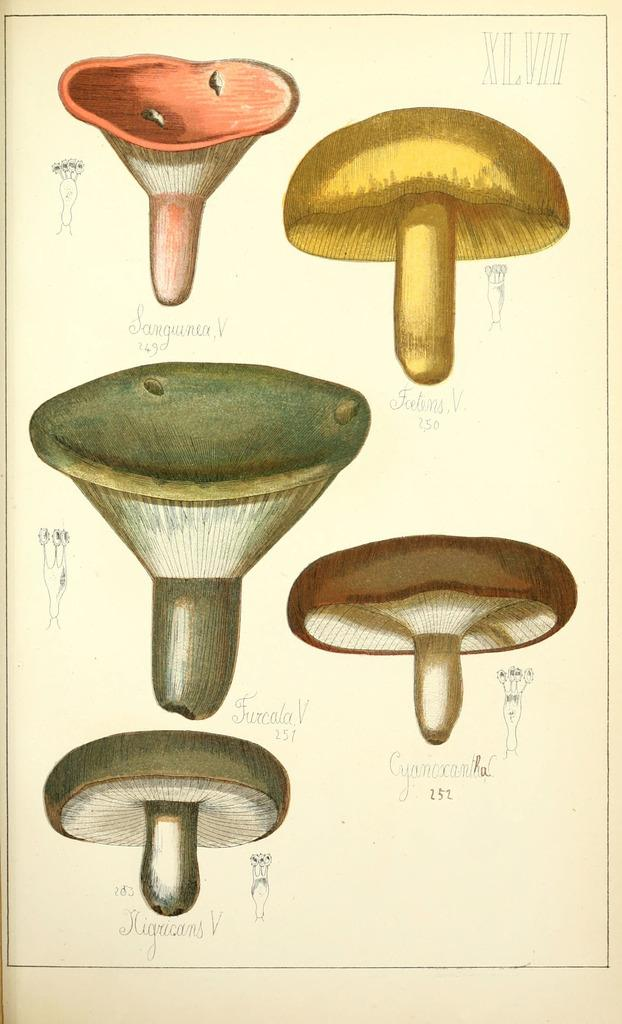What type of fungi can be seen in the image? There are mushrooms in the image. How many eyes can be seen on the mushrooms in the image? There are no eyes visible on the mushrooms in the image, as mushrooms do not have eyes. 